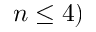<formula> <loc_0><loc_0><loc_500><loc_500>n \leq 4 )</formula> 